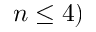<formula> <loc_0><loc_0><loc_500><loc_500>n \leq 4 )</formula> 